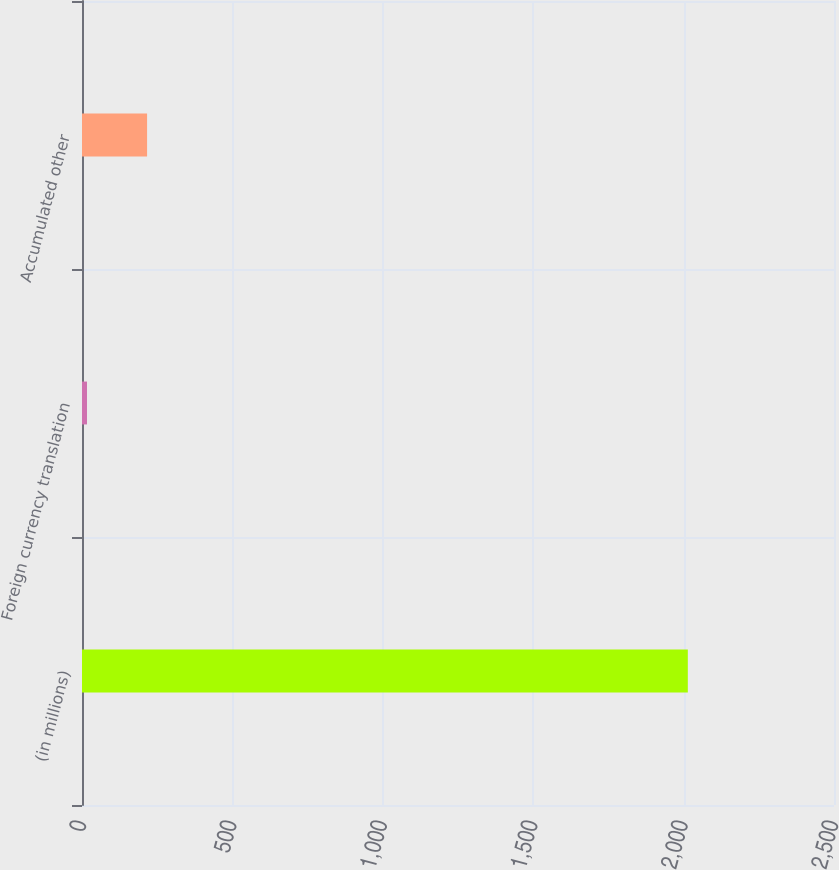Convert chart to OTSL. <chart><loc_0><loc_0><loc_500><loc_500><bar_chart><fcel>(in millions)<fcel>Foreign currency translation<fcel>Accumulated other<nl><fcel>2014<fcel>16.6<fcel>216.34<nl></chart> 